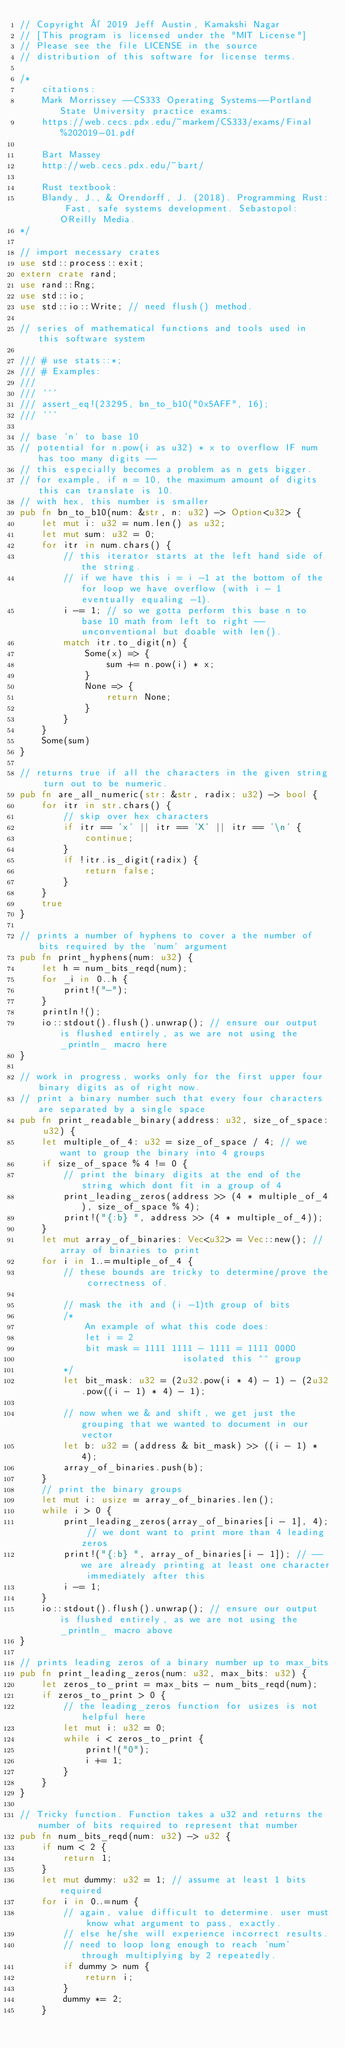<code> <loc_0><loc_0><loc_500><loc_500><_Rust_>// Copyright © 2019 Jeff Austin, Kamakshi Nagar
// [This program is licensed under the "MIT License"]
// Please see the file LICENSE in the source
// distribution of this software for license terms.

/*
    citations:
    Mark Morrissey --CS333 Operating Systems--Portland State University practice exams:
    https://web.cecs.pdx.edu/~markem/CS333/exams/Final%202019-01.pdf

    Bart Massey
    http://web.cecs.pdx.edu/~bart/

    Rust textbook:
    Blandy, J., & Orendorff, J. (2018). Programming Rust: Fast, safe systems development. Sebastopol: OReilly Media.
*/

// import necessary crates
use std::process::exit;
extern crate rand;
use rand::Rng;
use std::io;
use std::io::Write; // need flush() method.

// series of mathematical functions and tools used in this software system

/// # use stats::*;
/// # Examples:
///
/// ```
/// assert_eq!(23295, bn_to_b10("0x5AFF", 16);
/// ```

// base `n` to base 10
// potential for n.pow(i as u32) * x to overflow IF num has too many digits --
// this especially becomes a problem as n gets bigger.
// for example, if n = 10, the maximum amount of digits this can translate is 10.
// with hex, this number is smaller
pub fn bn_to_b10(num: &str, n: u32) -> Option<u32> {
    let mut i: u32 = num.len() as u32;
    let mut sum: u32 = 0;
    for itr in num.chars() {
        // this iterator starts at the left hand side of the string.
        // if we have this i = i -1 at the bottom of the for loop we have overflow (with i - 1 eventually equaling -1).
        i -= 1; // so we gotta perform this base n to base 10 math from left to right --unconventional but doable with len().
        match itr.to_digit(n) {
            Some(x) => {
                sum += n.pow(i) * x;
            }
            None => {
                return None;
            }
        }
    }
    Some(sum)
}

// returns true if all the characters in the given string turn out to be numeric.
pub fn are_all_numeric(str: &str, radix: u32) -> bool {
    for itr in str.chars() {
        // skip over hex characters
        if itr == 'x' || itr == 'X' || itr == '\n' {
            continue;
        }
        if !itr.is_digit(radix) {
            return false;
        }
    }
    true
}

// prints a number of hyphens to cover a the number of bits required by the `num` argument
pub fn print_hyphens(num: u32) {
    let h = num_bits_reqd(num);
    for _i in 0..h {
        print!("-");
    }
    println!();
    io::stdout().flush().unwrap(); // ensure our output is flushed entirely, as we are not using the _println_ macro here
}

// work in progress, works only for the first upper four binary digits as of right now.
// print a binary number such that every four characters are separated by a single space
pub fn print_readable_binary(address: u32, size_of_space: u32) {
    let multiple_of_4: u32 = size_of_space / 4; // we want to group the binary into 4 groups
    if size_of_space % 4 != 0 {
        // print the binary digits at the end of the string which dont fit in a group of 4
        print_leading_zeros(address >> (4 * multiple_of_4), size_of_space % 4);
        print!("{:b} ", address >> (4 * multiple_of_4));
    }
    let mut array_of_binaries: Vec<u32> = Vec::new(); // array of binaries to print
    for i in 1..=multiple_of_4 {
        // these bounds are tricky to determine/prove the correctness of.

        // mask the ith and (i -1)th group of bits
        /*
            An example of what this code does:
            let i = 2
            bit mask = 1111 1111 - 1111 = 1111 0000
                              isolated this ^^ group
        */
        let bit_mask: u32 = (2u32.pow(i * 4) - 1) - (2u32.pow((i - 1) * 4) - 1);

        // now when we & and shift, we get just the grouping that we wanted to document in our vector
        let b: u32 = (address & bit_mask) >> ((i - 1) * 4);
        array_of_binaries.push(b);
    }
    // print the binary groups
    let mut i: usize = array_of_binaries.len();
    while i > 0 {
        print_leading_zeros(array_of_binaries[i - 1], 4); // we dont want to print more than 4 leading zeros
        print!("{:b} ", array_of_binaries[i - 1]); // --we are already printing at least one character immediately after this
        i -= 1;
    }
    io::stdout().flush().unwrap(); // ensure our output is flushed entirely, as we are not using the _println_ macro above
}

// prints leading zeros of a binary number up to max_bits
pub fn print_leading_zeros(num: u32, max_bits: u32) {
    let zeros_to_print = max_bits - num_bits_reqd(num);
    if zeros_to_print > 0 {
        // the leading_zeros function for usizes is not helpful here
        let mut i: u32 = 0;
        while i < zeros_to_print {
            print!("0");
            i += 1;
        }
    }
}

// Tricky function. Function takes a u32 and returns the number of bits required to represent that number
pub fn num_bits_reqd(num: u32) -> u32 {
    if num < 2 {
        return 1;
    }
    let mut dummy: u32 = 1; // assume at least 1 bits required
    for i in 0..=num {
        // again, value difficult to determine. user must know what argument to pass, exactly.
        // else he/she will experience incorrect results.
        // need to loop long enough to reach `num` through multiplying by 2 repeatedly.
        if dummy > num {
            return i;
        }
        dummy *= 2;
    }</code> 